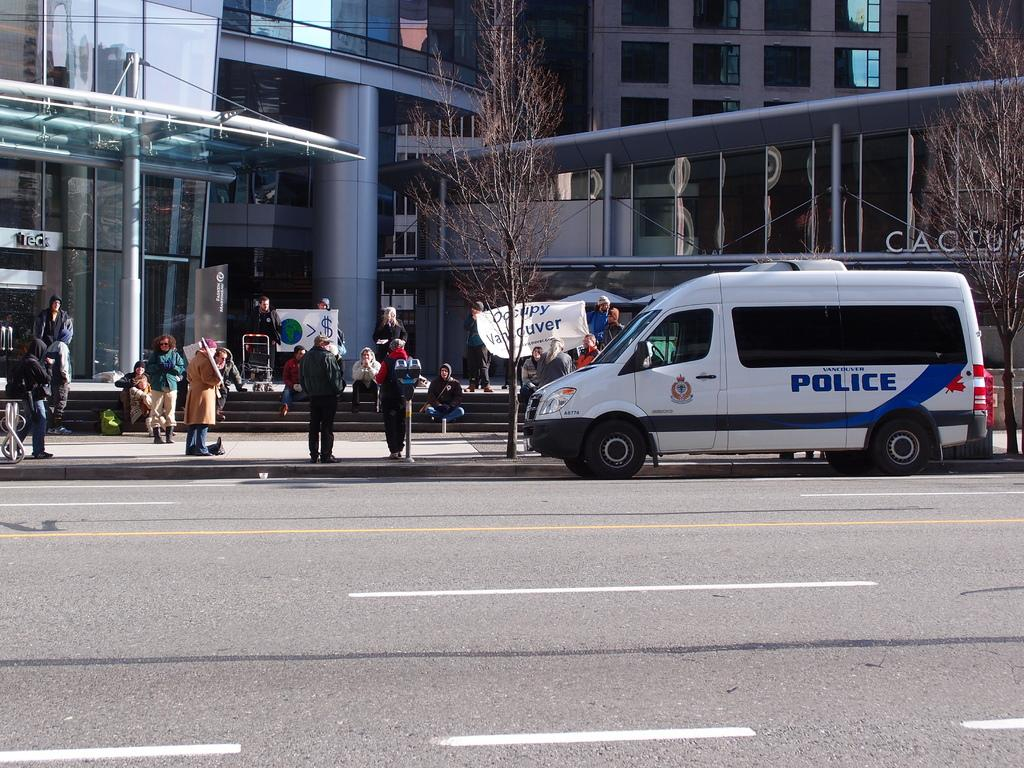<image>
Create a compact narrative representing the image presented. A white police van is parked outside a building where people are carrying signs and holding a protest outside a building. 